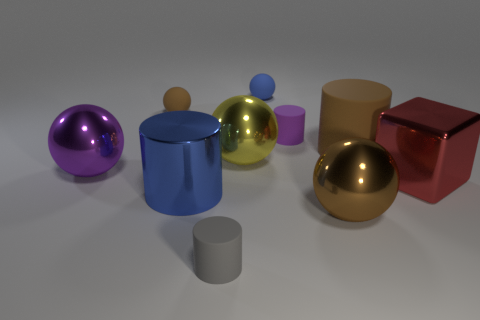The large rubber thing that is the same shape as the small gray rubber object is what color?
Your answer should be very brief. Brown. Are there more objects that are right of the brown rubber sphere than large cylinders?
Give a very brief answer. Yes. There is a big yellow metal object; is its shape the same as the rubber object on the right side of the tiny purple cylinder?
Give a very brief answer. No. There is a gray thing that is the same shape as the large brown rubber thing; what is its size?
Offer a very short reply. Small. Are there more big green rubber cubes than large matte things?
Ensure brevity in your answer.  No. Is the tiny brown thing the same shape as the red object?
Your response must be concise. No. What is the material of the big cube that is to the right of the purple object left of the yellow metallic sphere?
Offer a terse response. Metal. There is a thing that is the same color as the metal cylinder; what is it made of?
Provide a succinct answer. Rubber. Do the metal cylinder and the blue sphere have the same size?
Your answer should be very brief. No. There is a blue object in front of the purple rubber object; is there a large blue metal thing in front of it?
Your response must be concise. No. 